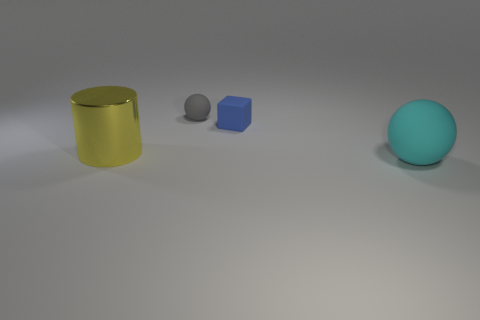Is there any other thing that has the same material as the yellow cylinder?
Offer a very short reply. No. There is a shiny object; are there any tiny gray balls to the left of it?
Provide a short and direct response. No. Is the number of blocks that are left of the small gray sphere the same as the number of cyan rubber things?
Your response must be concise. No. There is a gray matte thing that is the same shape as the cyan matte thing; what is its size?
Your response must be concise. Small. There is a yellow object; is its shape the same as the big object in front of the yellow cylinder?
Keep it short and to the point. No. How big is the ball left of the rubber thing on the right side of the block?
Ensure brevity in your answer.  Small. Are there an equal number of big yellow shiny cylinders left of the big yellow object and big rubber balls on the left side of the large rubber sphere?
Your response must be concise. Yes. There is a small matte object that is the same shape as the large cyan rubber object; what color is it?
Give a very brief answer. Gray. How many big balls have the same color as the big cylinder?
Provide a succinct answer. 0. Is the shape of the object that is behind the tiny blue block the same as  the cyan object?
Give a very brief answer. Yes. 